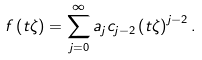Convert formula to latex. <formula><loc_0><loc_0><loc_500><loc_500>f \left ( t \zeta \right ) = \sum _ { j = 0 } ^ { \infty } a _ { j } c _ { j - 2 } \left ( t \zeta \right ) ^ { j - 2 } .</formula> 